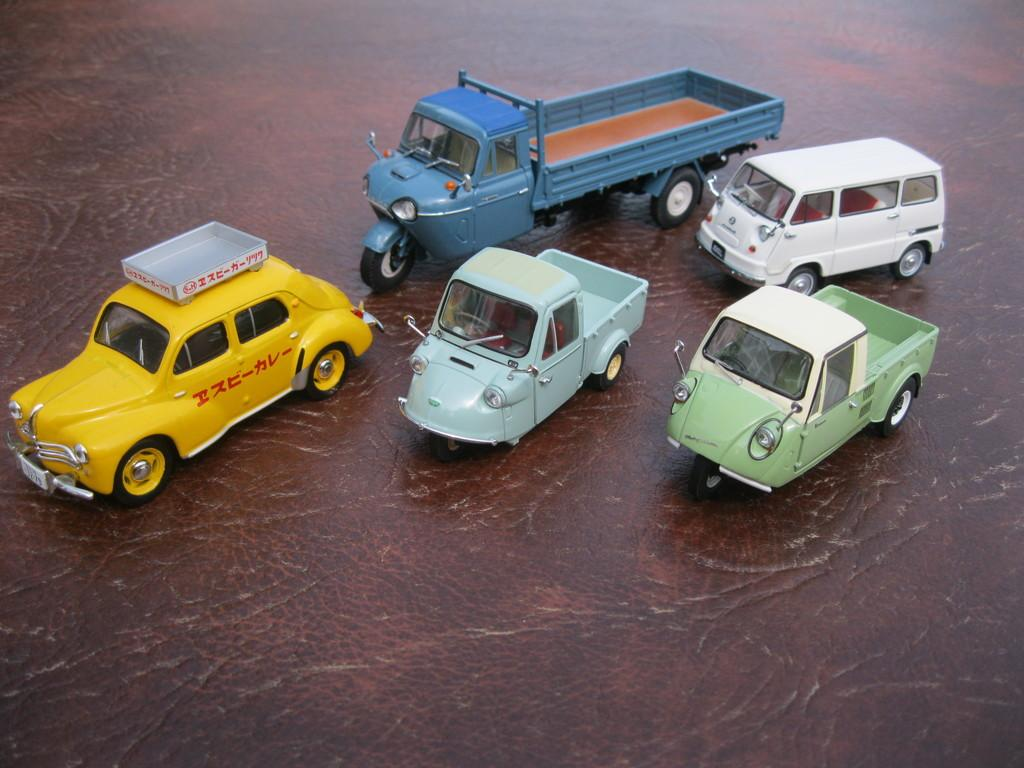<image>
Summarize the visual content of the image. Toy trucks and cars sit on a table, including a yellow cab with Asian lettering on the side. 